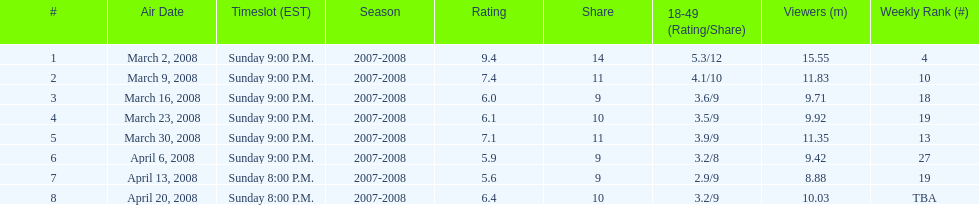The airing date with the maximum viewership March 2, 2008. 